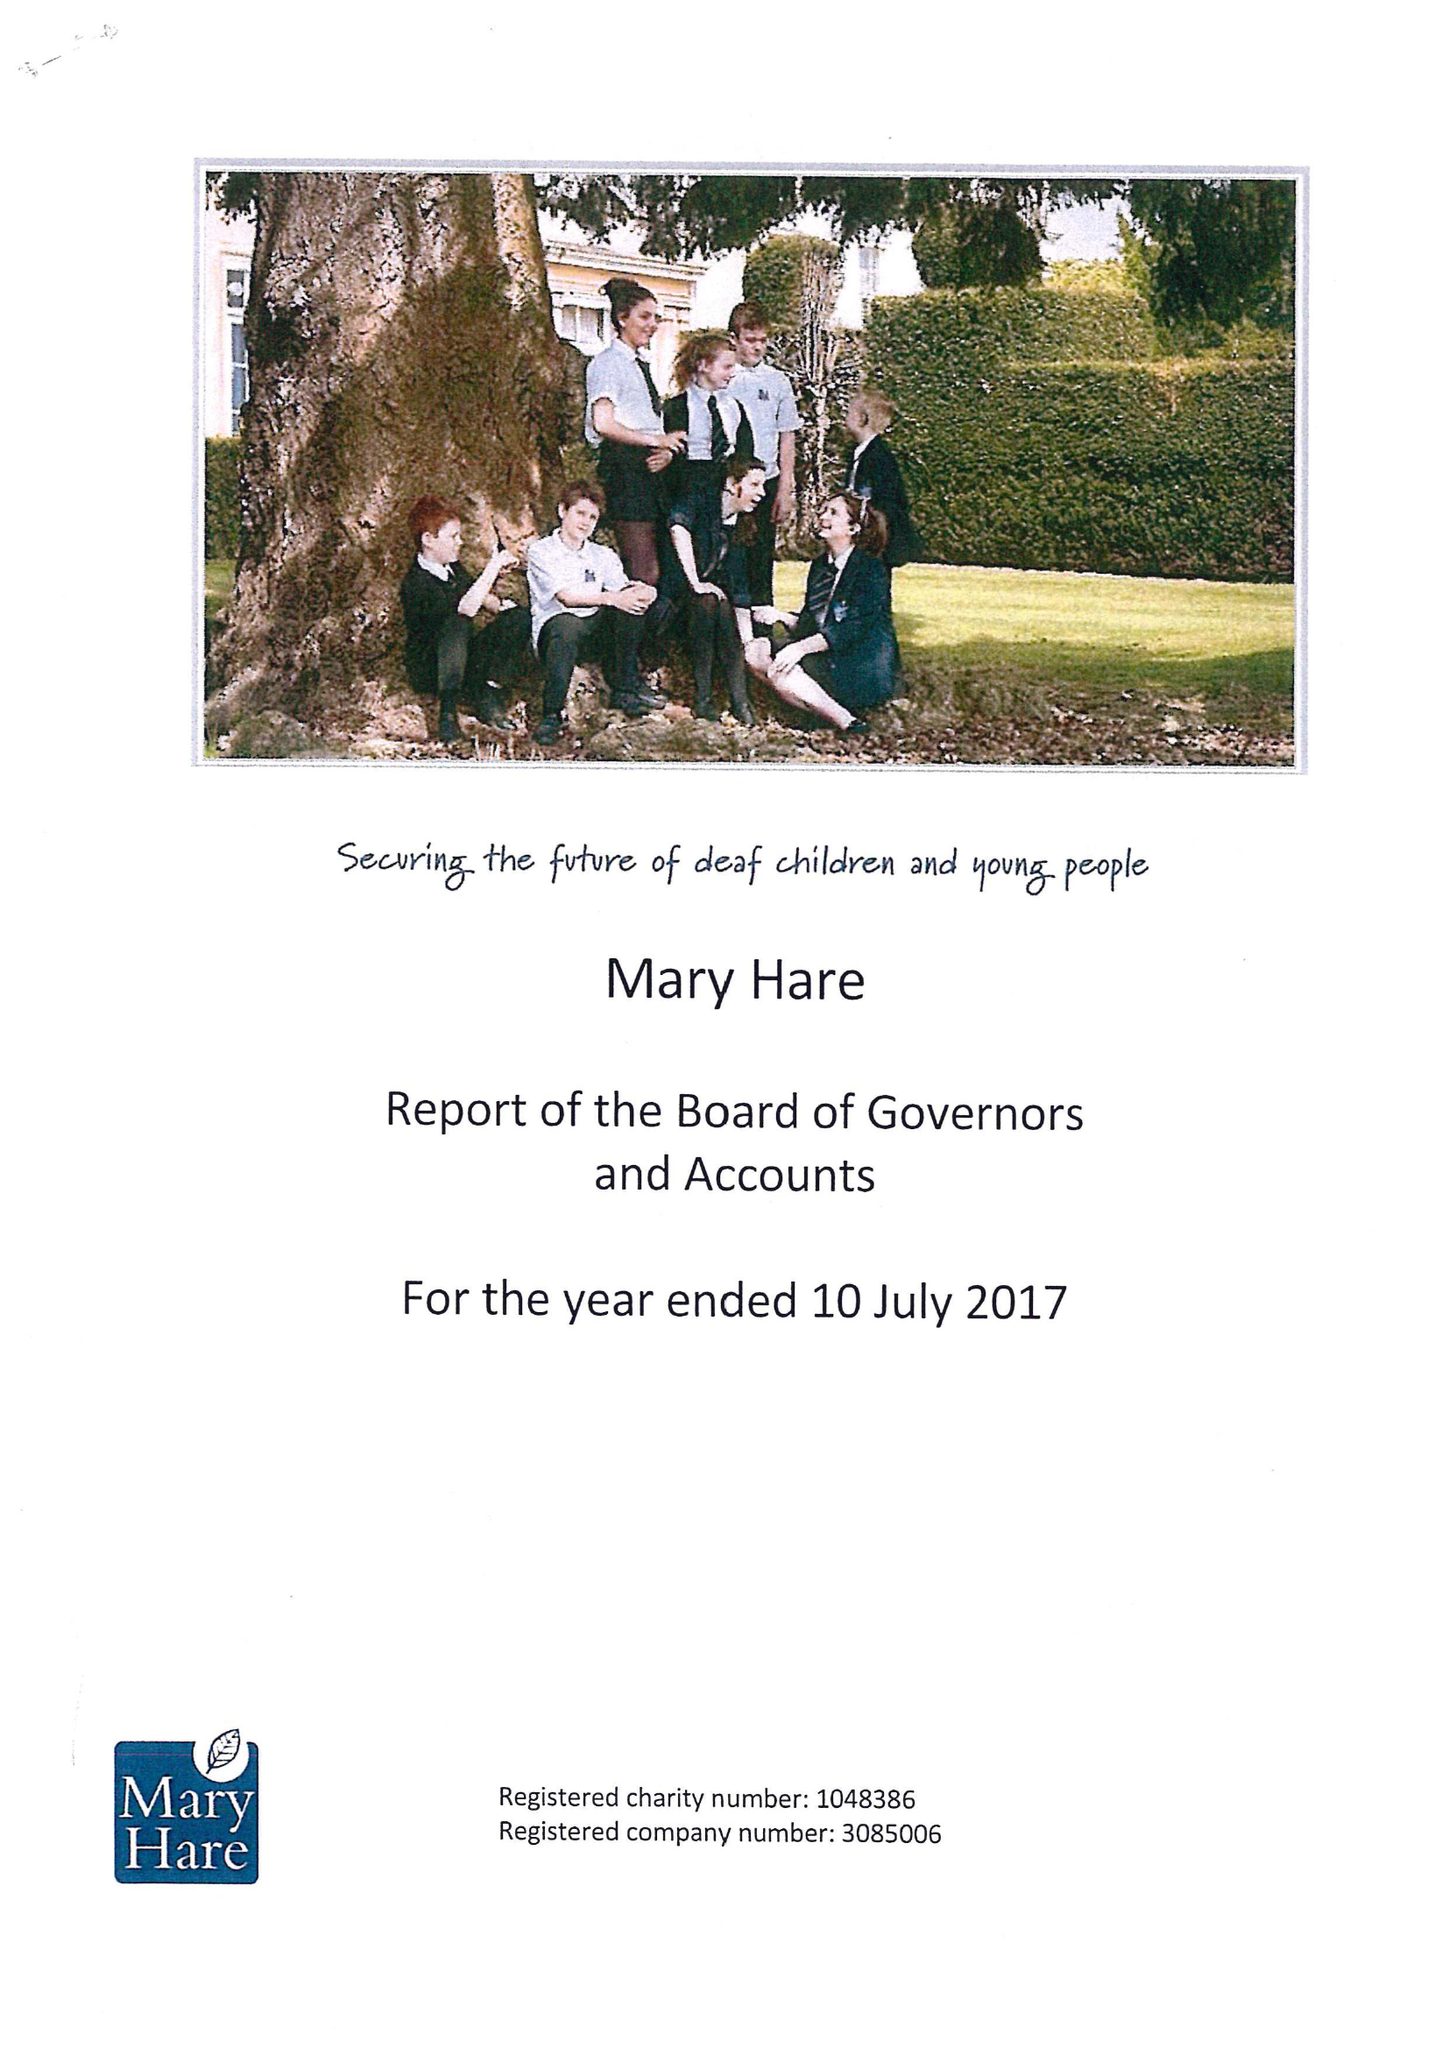What is the value for the charity_name?
Answer the question using a single word or phrase. Mary Hare 